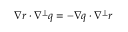<formula> <loc_0><loc_0><loc_500><loc_500>\nabla r \cdot \nabla ^ { \perp } q = - \nabla q \cdot \nabla ^ { \perp } r</formula> 